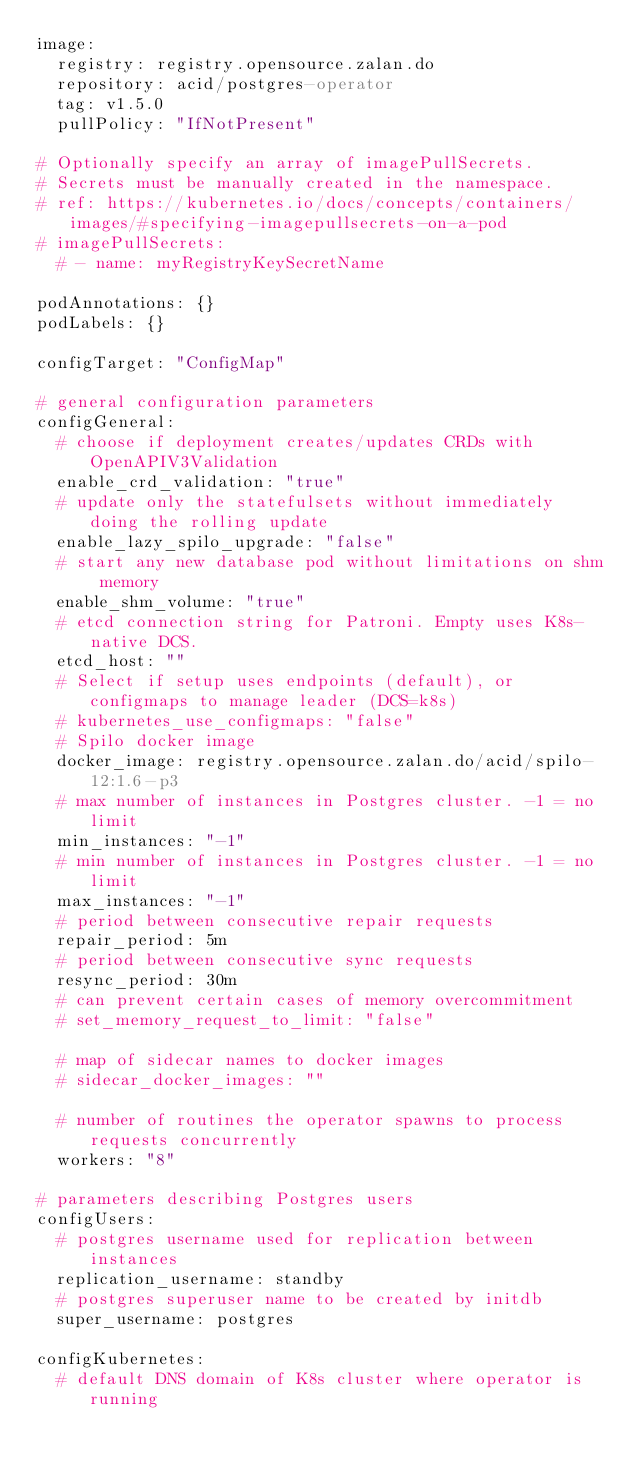<code> <loc_0><loc_0><loc_500><loc_500><_YAML_>image:
  registry: registry.opensource.zalan.do
  repository: acid/postgres-operator
  tag: v1.5.0
  pullPolicy: "IfNotPresent"

# Optionally specify an array of imagePullSecrets.
# Secrets must be manually created in the namespace.
# ref: https://kubernetes.io/docs/concepts/containers/images/#specifying-imagepullsecrets-on-a-pod
# imagePullSecrets:
  # - name: myRegistryKeySecretName

podAnnotations: {}
podLabels: {}

configTarget: "ConfigMap"

# general configuration parameters
configGeneral:
  # choose if deployment creates/updates CRDs with OpenAPIV3Validation
  enable_crd_validation: "true"
  # update only the statefulsets without immediately doing the rolling update
  enable_lazy_spilo_upgrade: "false"
  # start any new database pod without limitations on shm memory
  enable_shm_volume: "true"
  # etcd connection string for Patroni. Empty uses K8s-native DCS.
  etcd_host: ""
  # Select if setup uses endpoints (default), or configmaps to manage leader (DCS=k8s)
  # kubernetes_use_configmaps: "false"
  # Spilo docker image
  docker_image: registry.opensource.zalan.do/acid/spilo-12:1.6-p3
  # max number of instances in Postgres cluster. -1 = no limit
  min_instances: "-1"
  # min number of instances in Postgres cluster. -1 = no limit
  max_instances: "-1"
  # period between consecutive repair requests
  repair_period: 5m
  # period between consecutive sync requests
  resync_period: 30m
  # can prevent certain cases of memory overcommitment
  # set_memory_request_to_limit: "false"

  # map of sidecar names to docker images
  # sidecar_docker_images: ""

  # number of routines the operator spawns to process requests concurrently
  workers: "8"

# parameters describing Postgres users
configUsers:
  # postgres username used for replication between instances
  replication_username: standby
  # postgres superuser name to be created by initdb
  super_username: postgres

configKubernetes:
  # default DNS domain of K8s cluster where operator is running</code> 